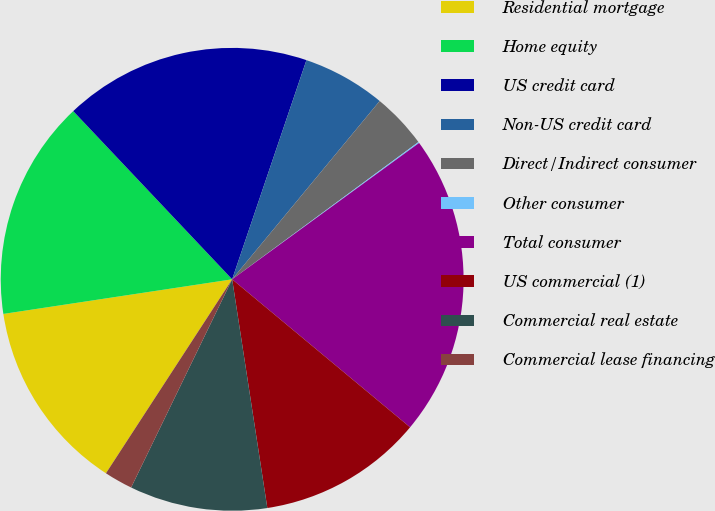Convert chart. <chart><loc_0><loc_0><loc_500><loc_500><pie_chart><fcel>Residential mortgage<fcel>Home equity<fcel>US credit card<fcel>Non-US credit card<fcel>Direct/Indirect consumer<fcel>Other consumer<fcel>Total consumer<fcel>US commercial (1)<fcel>Commercial real estate<fcel>Commercial lease financing<nl><fcel>13.43%<fcel>15.34%<fcel>17.25%<fcel>5.8%<fcel>3.89%<fcel>0.08%<fcel>21.07%<fcel>11.53%<fcel>9.62%<fcel>1.99%<nl></chart> 